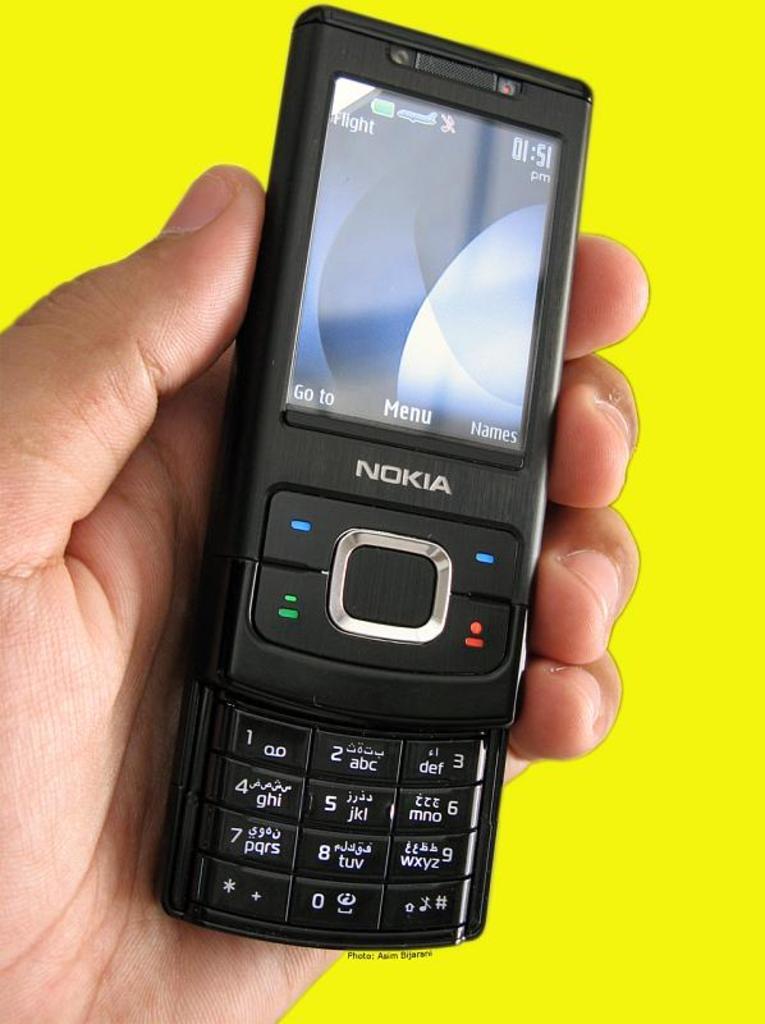What brand of phone is that?
Your answer should be compact. Nokia. What time is shown?
Offer a very short reply. 01:51. 